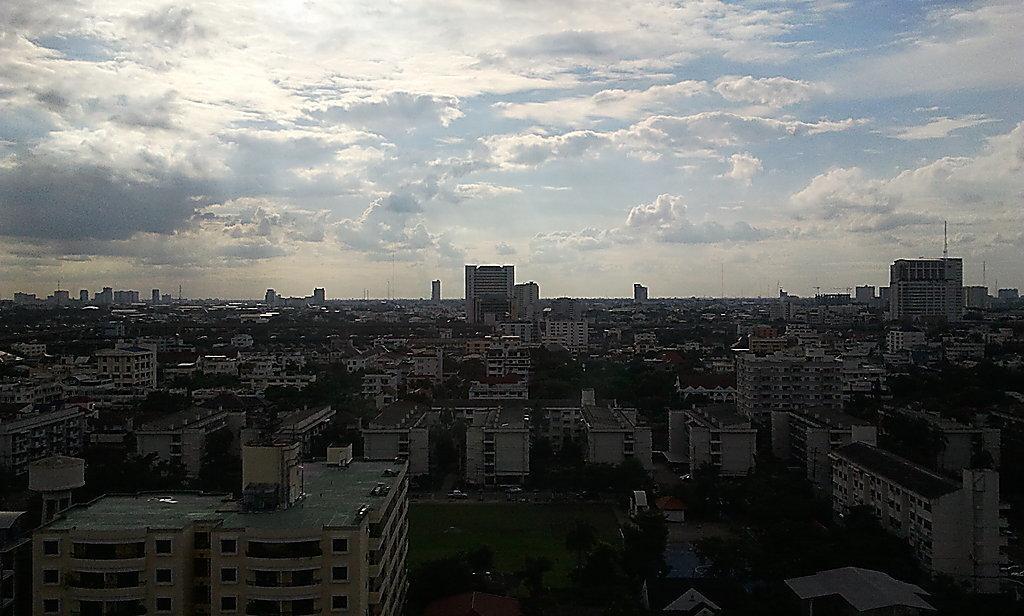Could you give a brief overview of what you see in this image? In this image we can see many buildings, windows, trees, poles, grass, vehicles on the road and clouds in the sky. 